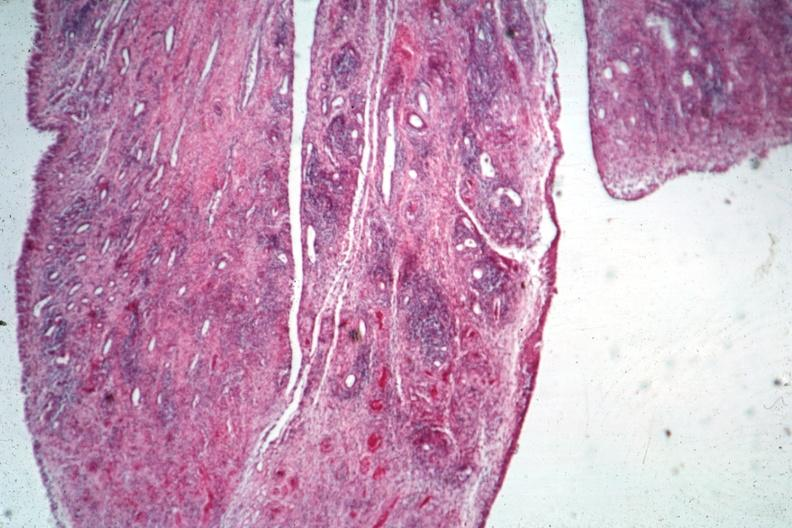what does this image show?
Answer the question using a single word or phrase. Typical lesion 